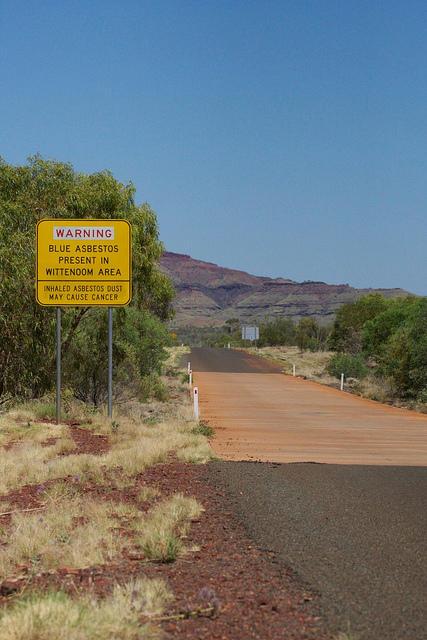Read and extract the text from this image. WARNING BLUE ASBESTOS PRESENT IN WITTENOOM AREA INHALED ASBESTOS OUSI MAY CAUSE CANCER 